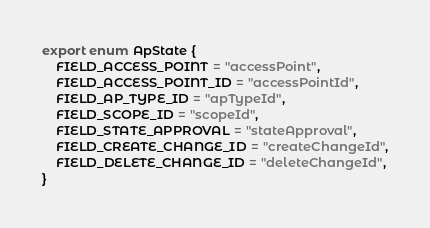Convert code to text. <code><loc_0><loc_0><loc_500><loc_500><_TypeScript_>export enum ApState {
    FIELD_ACCESS_POINT = "accessPoint",
    FIELD_ACCESS_POINT_ID = "accessPointId",
    FIELD_AP_TYPE_ID = "apTypeId",
    FIELD_SCOPE_ID = "scopeId",
    FIELD_STATE_APPROVAL = "stateApproval",
    FIELD_CREATE_CHANGE_ID = "createChangeId",
    FIELD_DELETE_CHANGE_ID = "deleteChangeId",
}
</code> 